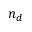<formula> <loc_0><loc_0><loc_500><loc_500>n _ { d }</formula> 